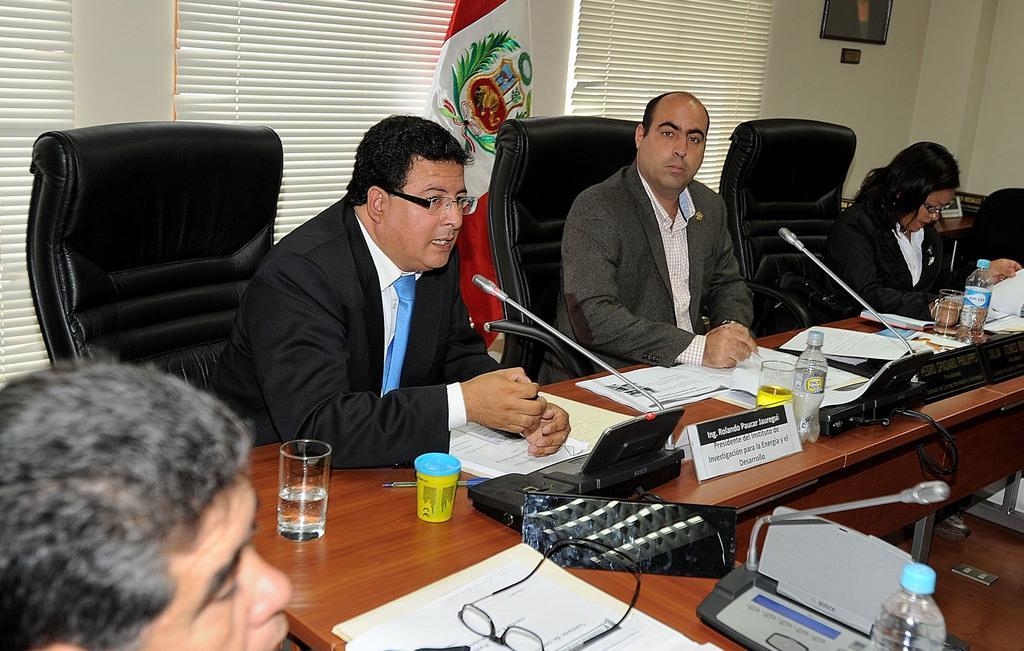Describe this image in one or two sentences. On the left side, there is a person. In front of him, there is a bottle, a spectacle on the documents, a microphone and other objects arranged. In the background, there are three persons sitting on the chairs in front of a table, on which there are microphones, bottles, glasses, documents and other objects arranged, there is a flag, a curtain and a photo frame attached to a wall. 